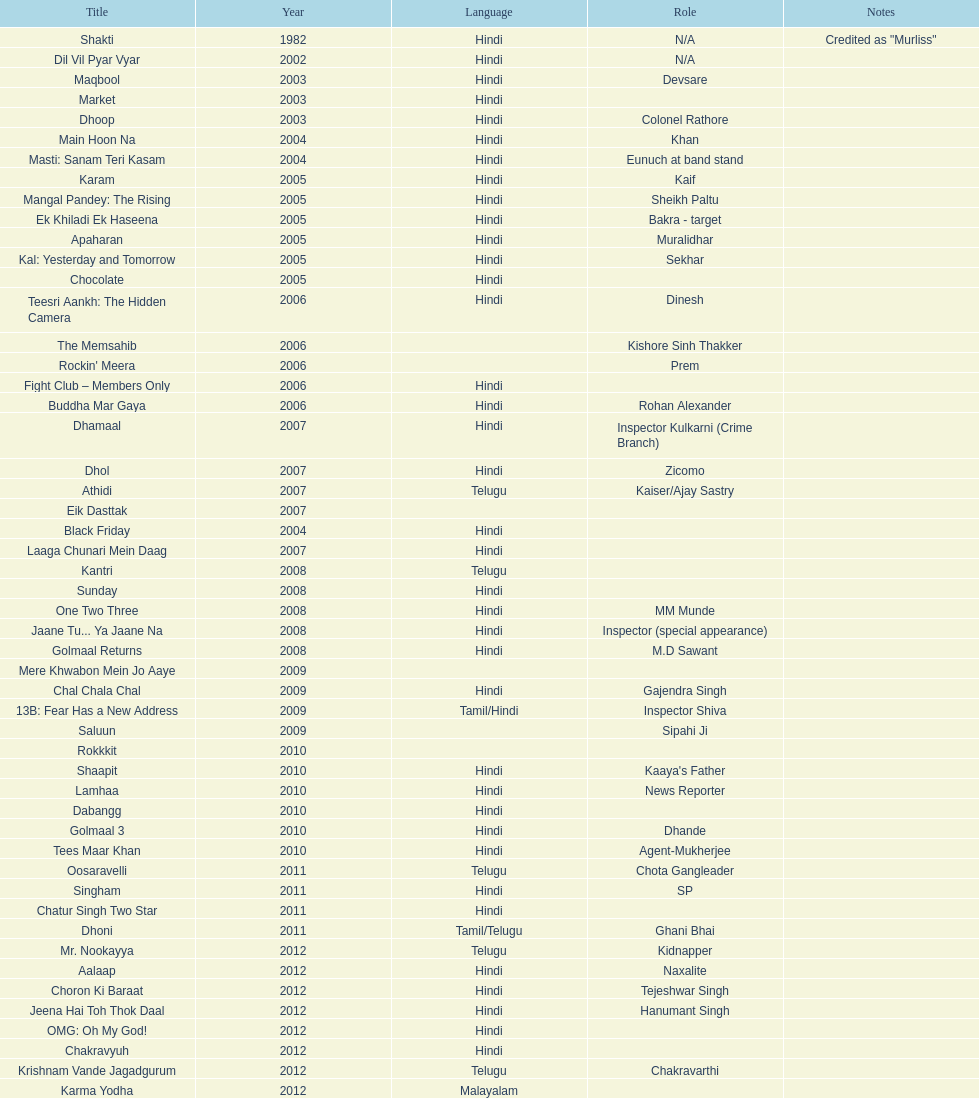What was the final malayalam film featuring this actor? Karma Yodha. 